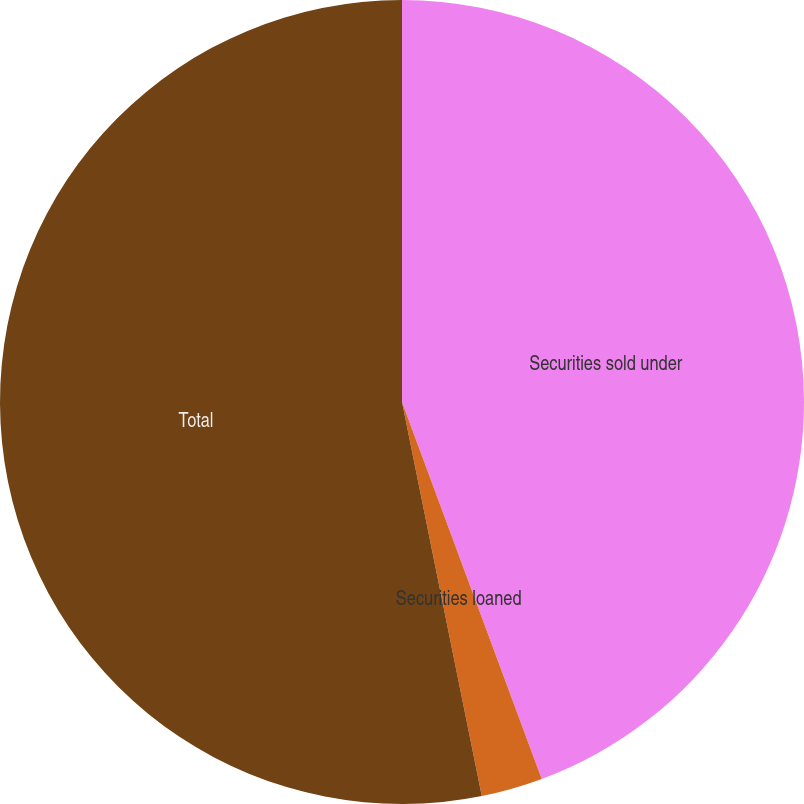<chart> <loc_0><loc_0><loc_500><loc_500><pie_chart><fcel>Securities sold under<fcel>Securities loaned<fcel>Total<nl><fcel>44.35%<fcel>2.47%<fcel>53.18%<nl></chart> 